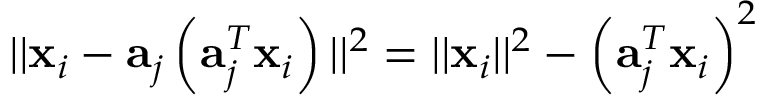<formula> <loc_0><loc_0><loc_500><loc_500>| | { x } _ { i } - { a } _ { j } \left ( { a } _ { j } ^ { T } { x } _ { i } \right ) | | ^ { 2 } = | | { x } _ { i } | | ^ { 2 } - \left ( { a } _ { j } ^ { T } { x } _ { i } \right ) ^ { 2 }</formula> 